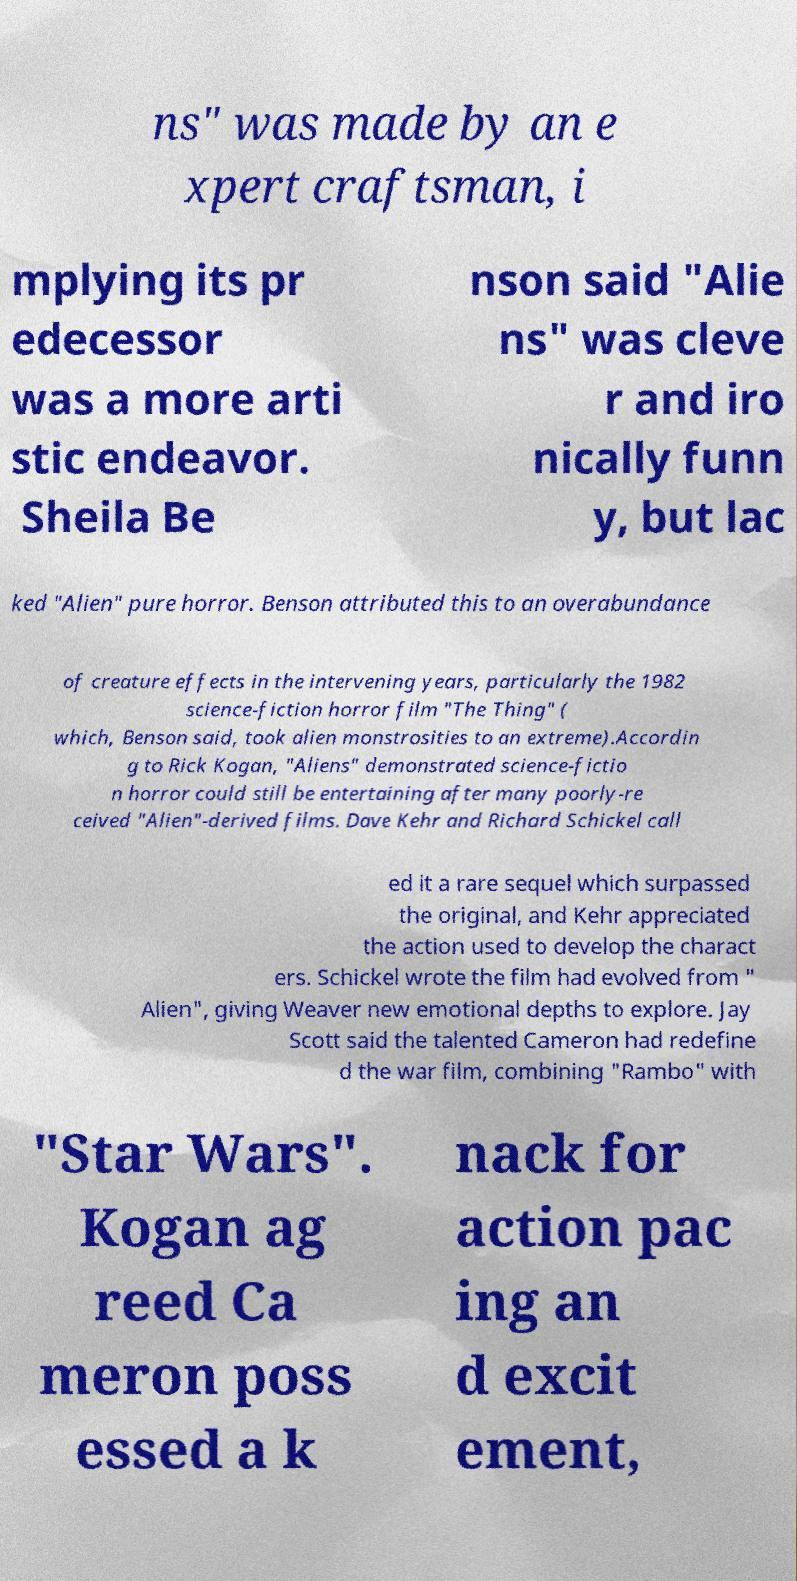What messages or text are displayed in this image? I need them in a readable, typed format. ns" was made by an e xpert craftsman, i mplying its pr edecessor was a more arti stic endeavor. Sheila Be nson said "Alie ns" was cleve r and iro nically funn y, but lac ked "Alien" pure horror. Benson attributed this to an overabundance of creature effects in the intervening years, particularly the 1982 science-fiction horror film "The Thing" ( which, Benson said, took alien monstrosities to an extreme).Accordin g to Rick Kogan, "Aliens" demonstrated science-fictio n horror could still be entertaining after many poorly-re ceived "Alien"-derived films. Dave Kehr and Richard Schickel call ed it a rare sequel which surpassed the original, and Kehr appreciated the action used to develop the charact ers. Schickel wrote the film had evolved from " Alien", giving Weaver new emotional depths to explore. Jay Scott said the talented Cameron had redefine d the war film, combining "Rambo" with "Star Wars". Kogan ag reed Ca meron poss essed a k nack for action pac ing an d excit ement, 